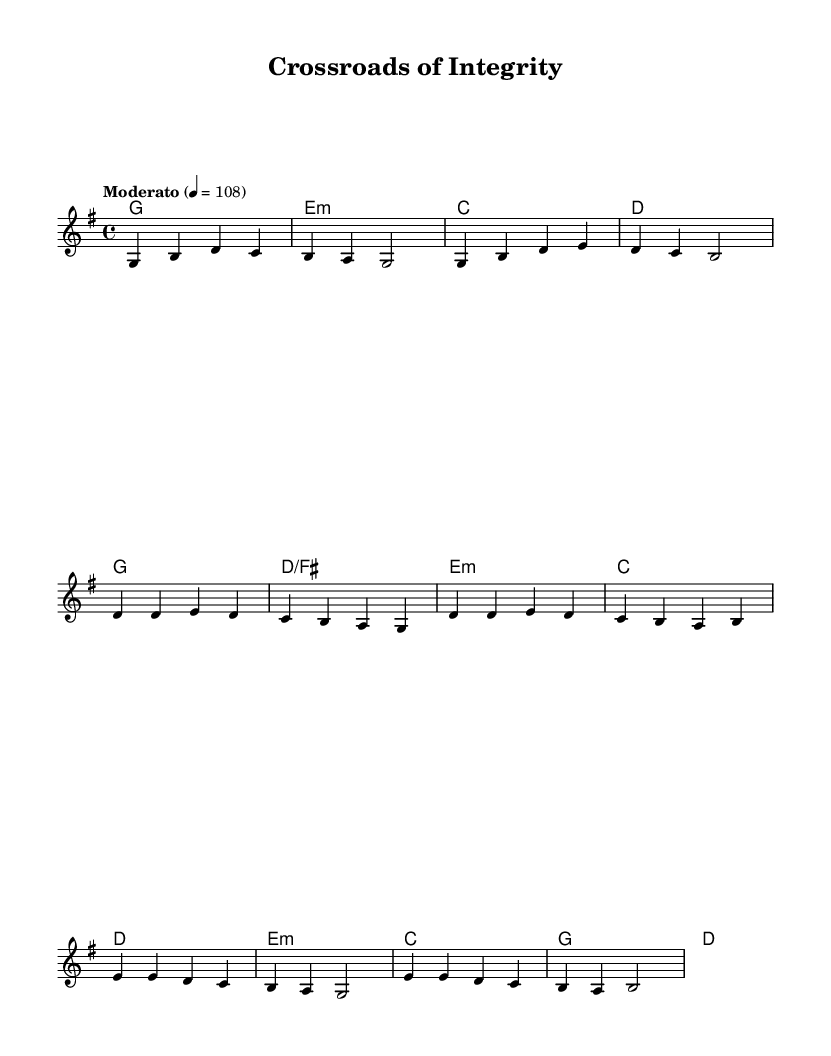What is the key signature of this music? The key signature is G major, which has one sharp (F#). The presence of the F# note in the melody and chords indicates that the music is set in G major.
Answer: G major What is the time signature of the piece? The time signature is indicated at the beginning of the score as 4/4. This means there are four beats per measure.
Answer: 4/4 What is the tempo marking of the piece? The tempo marking is indicated as "Moderato" with a metronome marking of 108, meaning the piece should be played at a moderate speed, roughly at 108 beats per minute.
Answer: Moderato, 108 How many verses are present in the music? The sheet music contains one verse before the chorus, which can be identified by the arrangement of the lyrics and the sections marked in the score.
Answer: One What do the bridge lyrics focus on? The bridge lyrics emphasize the importance of choices defining identity and legacy, as evidenced by the phrases "Every choice defines us" and "Let's build a legacy of trust". This reasoning involves analyzing the thematic content of the bridge section of the lyrics.
Answer: Choices defining identity and legacy What chord follows the first melody note in the verse? The first melody note in the verse is G, and it is accompanied by the G chord (the tonic chord). This can be determined by examining the harmonies written alongside the melody line.
Answer: G What is the focal theme of the chorus lyrics? The chorus lyrics focus on integrity and guidance in decision-making, as expressed in lines about integrity being the compass for choices. This is deduced from the repeated motifs and messages in the chorus section of the lyrics.
Answer: Integrity and guidance in decision-making 